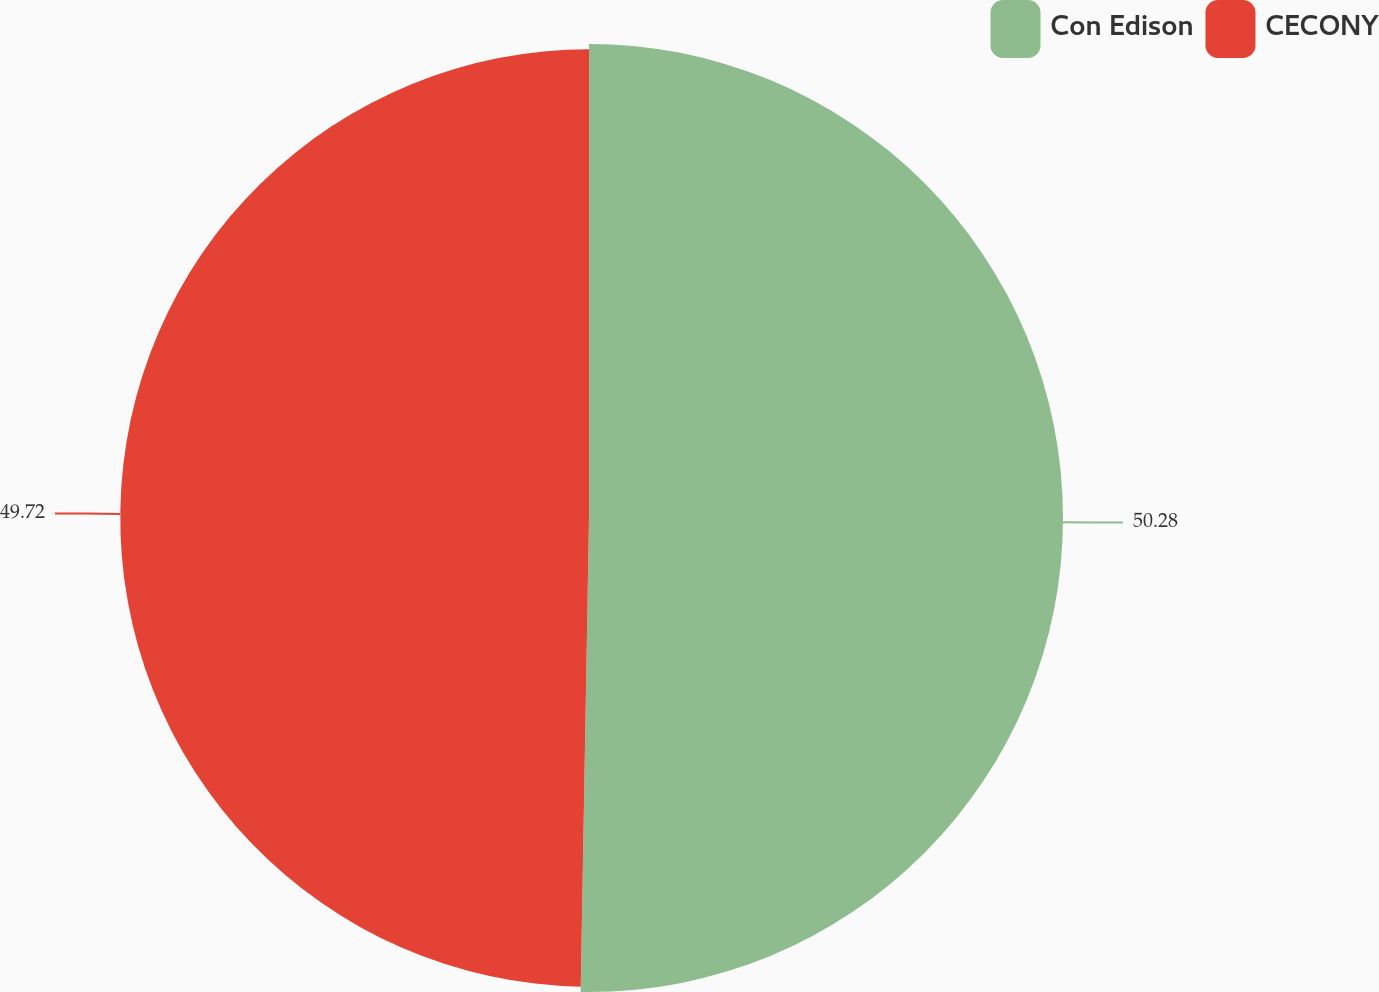Convert chart. <chart><loc_0><loc_0><loc_500><loc_500><pie_chart><fcel>Con Edison<fcel>CECONY<nl><fcel>50.28%<fcel>49.72%<nl></chart> 